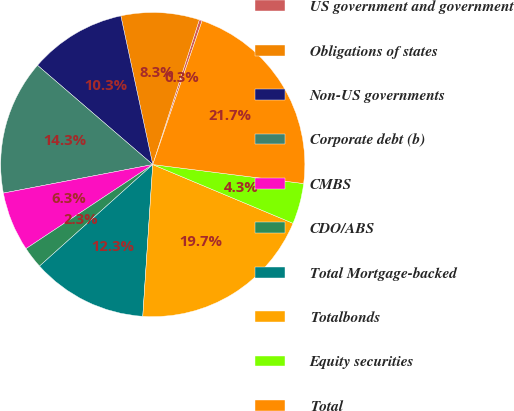Convert chart. <chart><loc_0><loc_0><loc_500><loc_500><pie_chart><fcel>US government and government<fcel>Obligations of states<fcel>Non-US governments<fcel>Corporate debt (b)<fcel>CMBS<fcel>CDO/ABS<fcel>Total Mortgage-backed<fcel>Totalbonds<fcel>Equity securities<fcel>Total<nl><fcel>0.31%<fcel>8.32%<fcel>10.32%<fcel>14.32%<fcel>6.32%<fcel>2.31%<fcel>12.32%<fcel>19.73%<fcel>4.32%<fcel>21.73%<nl></chart> 